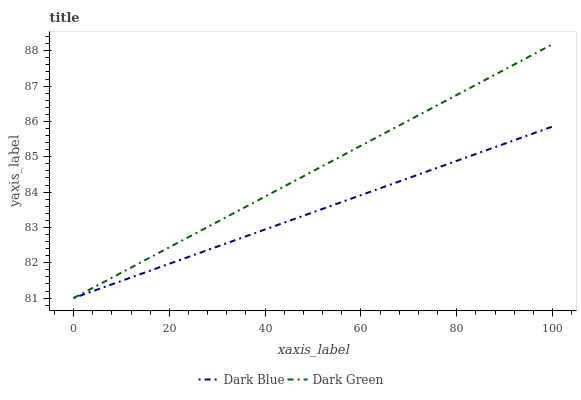Does Dark Blue have the minimum area under the curve?
Answer yes or no. Yes. Does Dark Green have the maximum area under the curve?
Answer yes or no. Yes. Does Dark Green have the minimum area under the curve?
Answer yes or no. No. Is Dark Green the smoothest?
Answer yes or no. Yes. Is Dark Blue the roughest?
Answer yes or no. Yes. Is Dark Green the roughest?
Answer yes or no. No. Does Dark Blue have the lowest value?
Answer yes or no. Yes. Does Dark Green have the highest value?
Answer yes or no. Yes. Does Dark Green intersect Dark Blue?
Answer yes or no. Yes. Is Dark Green less than Dark Blue?
Answer yes or no. No. Is Dark Green greater than Dark Blue?
Answer yes or no. No. 